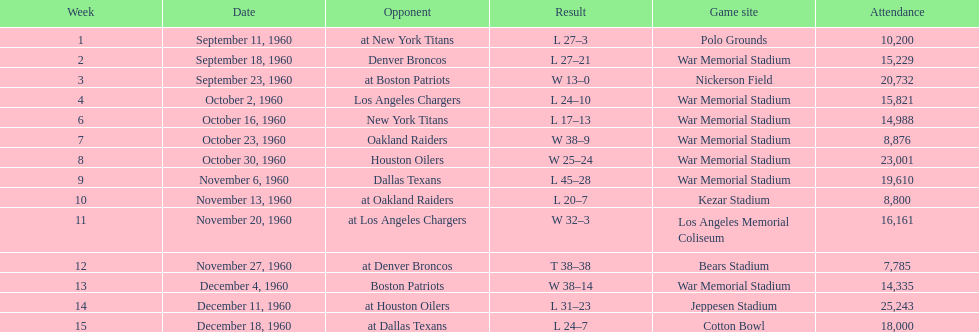Who was the opponent during for first week? New York Titans. 